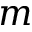Convert formula to latex. <formula><loc_0><loc_0><loc_500><loc_500>m</formula> 